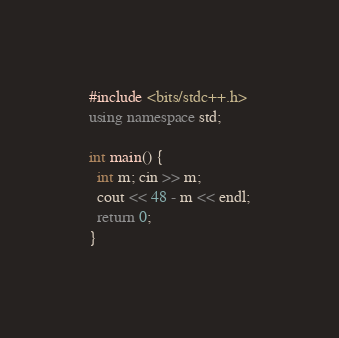<code> <loc_0><loc_0><loc_500><loc_500><_C++_>#include <bits/stdc++.h>
using namespace std;

int main() {
  int m; cin >> m;
  cout << 48 - m << endl;
  return 0;
}
</code> 